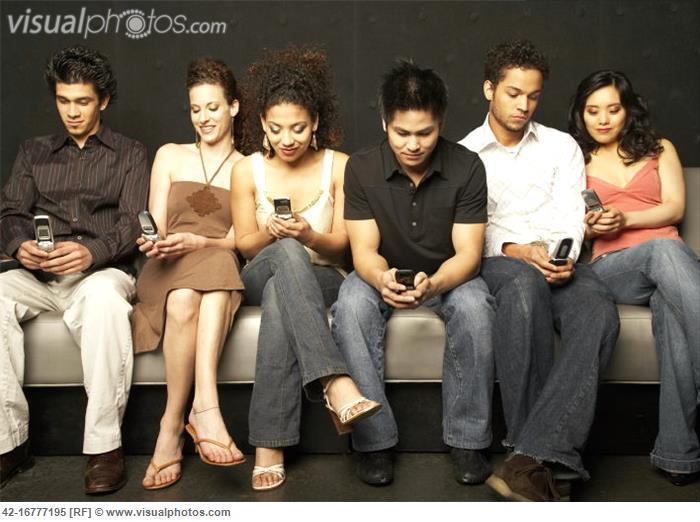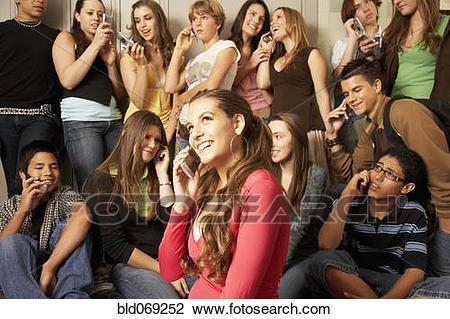The first image is the image on the left, the second image is the image on the right. Evaluate the accuracy of this statement regarding the images: "In the right image people are talking on their phones.". Is it true? Answer yes or no. Yes. The first image is the image on the left, the second image is the image on the right. Considering the images on both sides, is "An image shows four people standing in a line in front of a brick wall checking their phones." valid? Answer yes or no. No. 